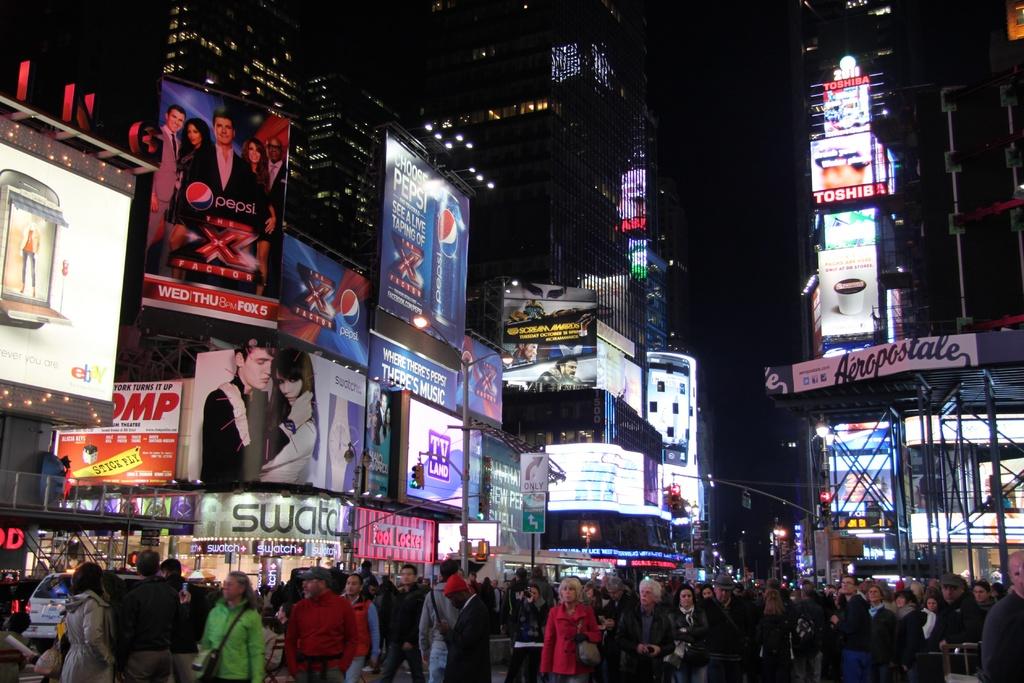What soda brand is shown on the x factor billboard?
Your answer should be very brief. Pepsi. What store is advertised on the right>?
Offer a terse response. Aeropostale. 